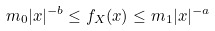Convert formula to latex. <formula><loc_0><loc_0><loc_500><loc_500>m _ { 0 } | x | ^ { - b } \leq f _ { X } ( x ) \leq m _ { 1 } | x | ^ { - a }</formula> 